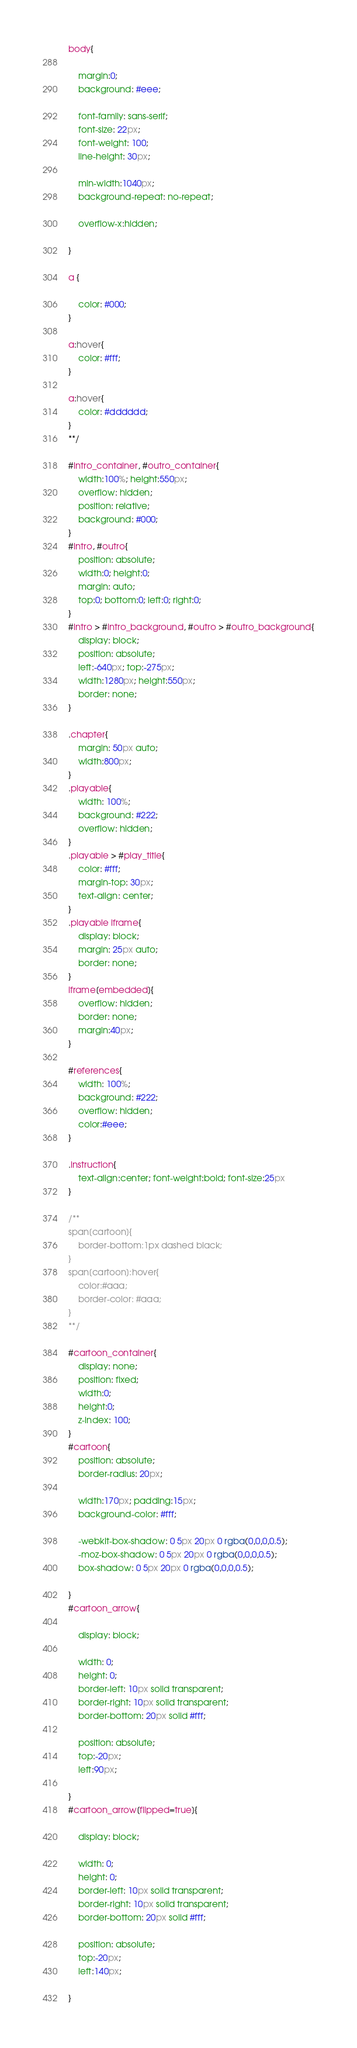Convert code to text. <code><loc_0><loc_0><loc_500><loc_500><_CSS_>body{

	margin:0;
	background: #eee;

	font-family: sans-serif;
	font-size: 22px;
	font-weight: 100;
	line-height: 30px;

	min-width:1040px;
	background-repeat: no-repeat;

	overflow-x:hidden;

}

a {

	color: #000;
}

a:hover{
	color: #fff;
}

a:hover{
	color: #dddddd;
}
**/

#intro_container, #outro_container{
	width:100%; height:550px;
	overflow: hidden;
	position: relative;
	background: #000;
}
#intro, #outro{
	position: absolute;
	width:0; height:0;
	margin: auto;
	top:0; bottom:0; left:0; right:0;
}
#intro > #intro_background, #outro > #outro_background{
	display: block;
	position: absolute;
	left:-640px; top:-275px;
	width:1280px; height:550px;
	border: none;
}

.chapter{
	margin: 50px auto;
	width:800px;
}
.playable{
	width: 100%;
	background: #222;
	overflow: hidden;
}
.playable > #play_title{
	color: #fff;
	margin-top: 30px;
	text-align: center;
}
.playable iframe{
	display: block;
	margin: 25px auto;
	border: none;
}
iframe[embedded]{
	overflow: hidden;
	border: none;
	margin:40px;
}

#references{
	width: 100%;
	background: #222;
	overflow: hidden;
	color:#eee;
}

.instruction{
	text-align:center; font-weight:bold; font-size:25px
}

/**
span[cartoon]{
	border-bottom:1px dashed black;
}
span[cartoon]:hover{
	color:#aaa;
	border-color: #aaa;
}
**/

#cartoon_container{
	display: none;
	position: fixed;
	width:0;
	height:0;
	z-index: 100;
}
#cartoon{
	position: absolute;
	border-radius: 20px;

	width:170px; padding:15px;
	background-color: #fff;

	-webkit-box-shadow: 0 5px 20px 0 rgba(0,0,0,0.5);
	-moz-box-shadow: 0 5px 20px 0 rgba(0,0,0,0.5);
	box-shadow: 0 5px 20px 0 rgba(0,0,0,0.5);

}
#cartoon_arrow{

	display: block;

	width: 0;
	height: 0;
	border-left: 10px solid transparent;
	border-right: 10px solid transparent;
	border-bottom: 20px solid #fff;

	position: absolute;
	top:-20px;
	left:90px;

}
#cartoon_arrow[flipped=true]{

	display: block;

	width: 0;
	height: 0;
	border-left: 10px solid transparent;
	border-right: 10px solid transparent;
	border-bottom: 20px solid #fff;

	position: absolute;
	top:-20px;
	left:140px;

}
</code> 